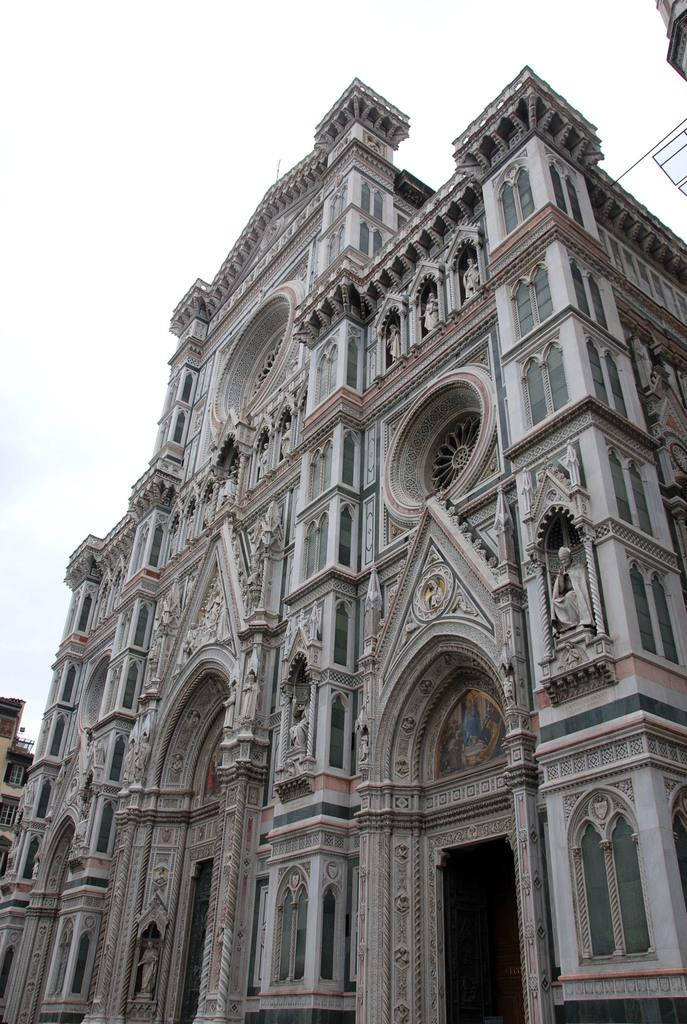What type of structure is shown in the image? The image depicts a palace. What architectural features can be seen on the palace? There are windows and statues visible on the palace. What else can be seen in the image besides the palace? There is a building visible in the distance. How would you describe the weather based on the image? The sky appears cloudy in the image. What type of vehicle is parked in front of the palace in the image? There is no vehicle visible in the image; it only shows the palace, windows, statues, a building in the distance, and a cloudy sky. 